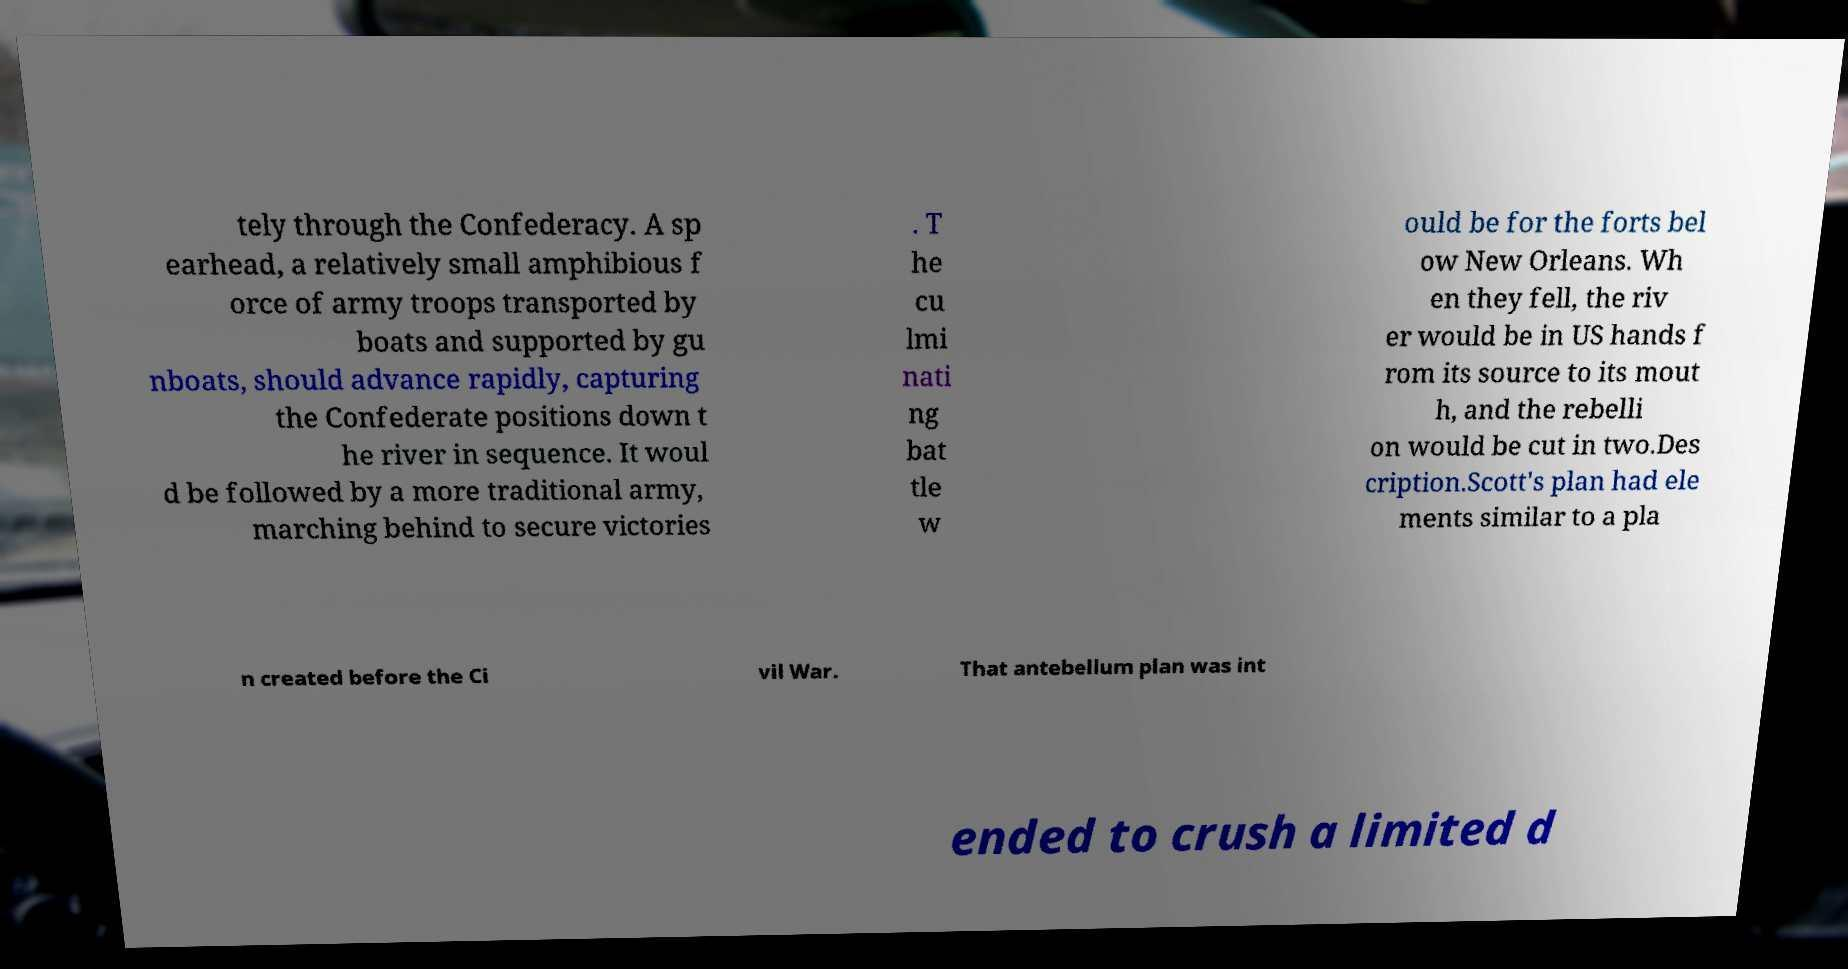Could you assist in decoding the text presented in this image and type it out clearly? tely through the Confederacy. A sp earhead, a relatively small amphibious f orce of army troops transported by boats and supported by gu nboats, should advance rapidly, capturing the Confederate positions down t he river in sequence. It woul d be followed by a more traditional army, marching behind to secure victories . T he cu lmi nati ng bat tle w ould be for the forts bel ow New Orleans. Wh en they fell, the riv er would be in US hands f rom its source to its mout h, and the rebelli on would be cut in two.Des cription.Scott's plan had ele ments similar to a pla n created before the Ci vil War. That antebellum plan was int ended to crush a limited d 